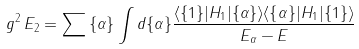<formula> <loc_0><loc_0><loc_500><loc_500>g ^ { 2 } \, E _ { 2 } = \sum { \{ \alpha \} } \int d \{ \alpha \} { \frac { \langle \{ 1 \} | H _ { 1 } | \{ \alpha \} \rangle \langle \{ \alpha \} | H _ { 1 } | \{ 1 \} \rangle } { E _ { \alpha } - E } }</formula> 